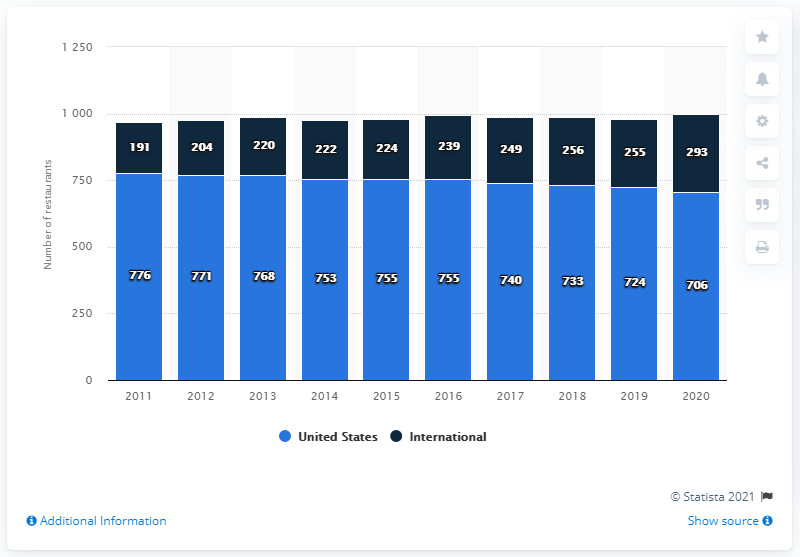Highlight a few significant elements in this photo. In 2020, the total number of restaurants was approximately 999. As of 2021, the largest share of Outback Steakhouse's restaurants was located in the United States. The highest value of the blue bar is 776. 